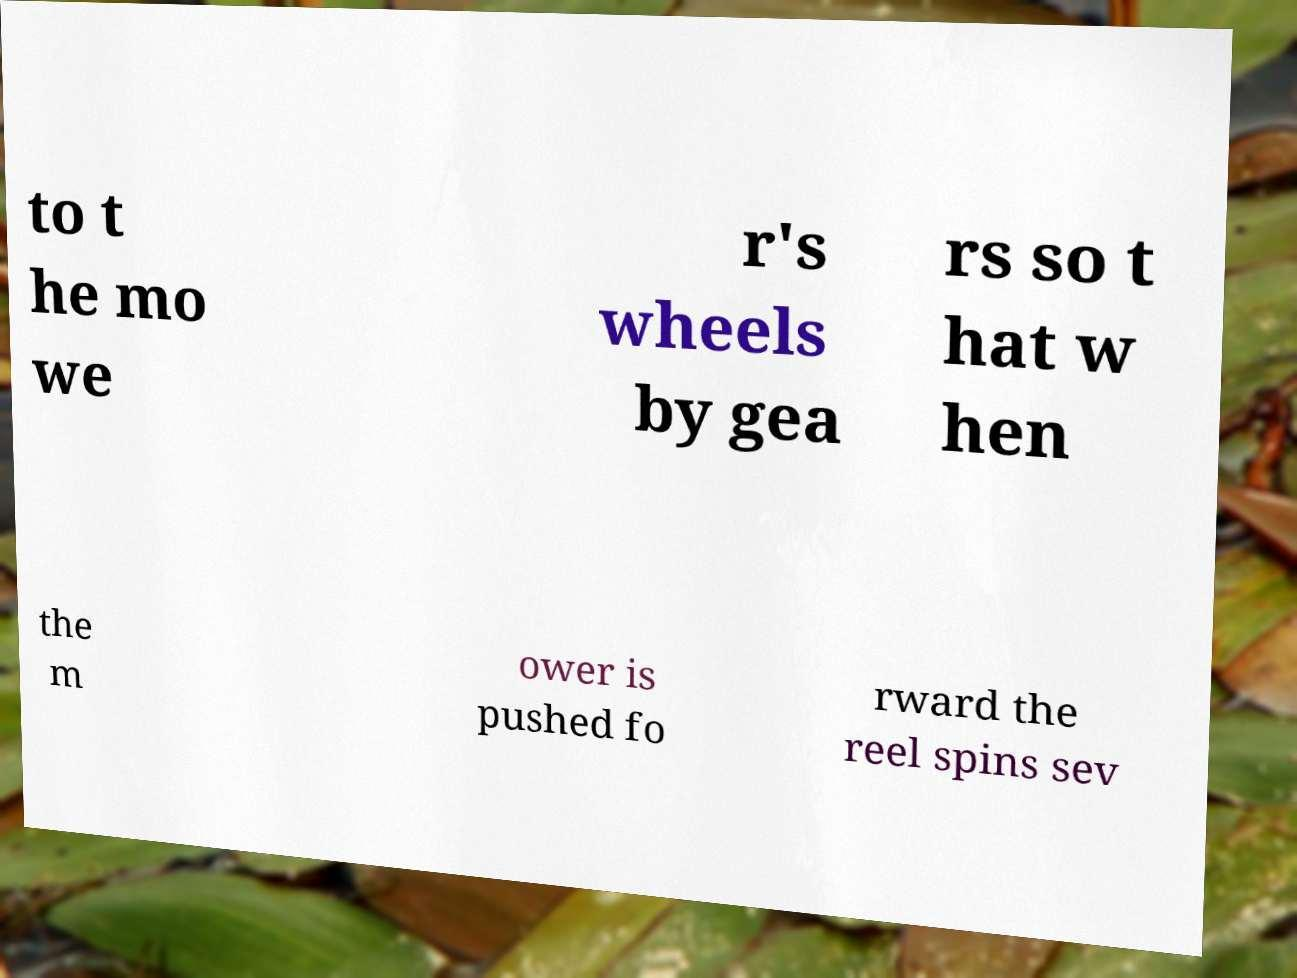Could you extract and type out the text from this image? to t he mo we r's wheels by gea rs so t hat w hen the m ower is pushed fo rward the reel spins sev 